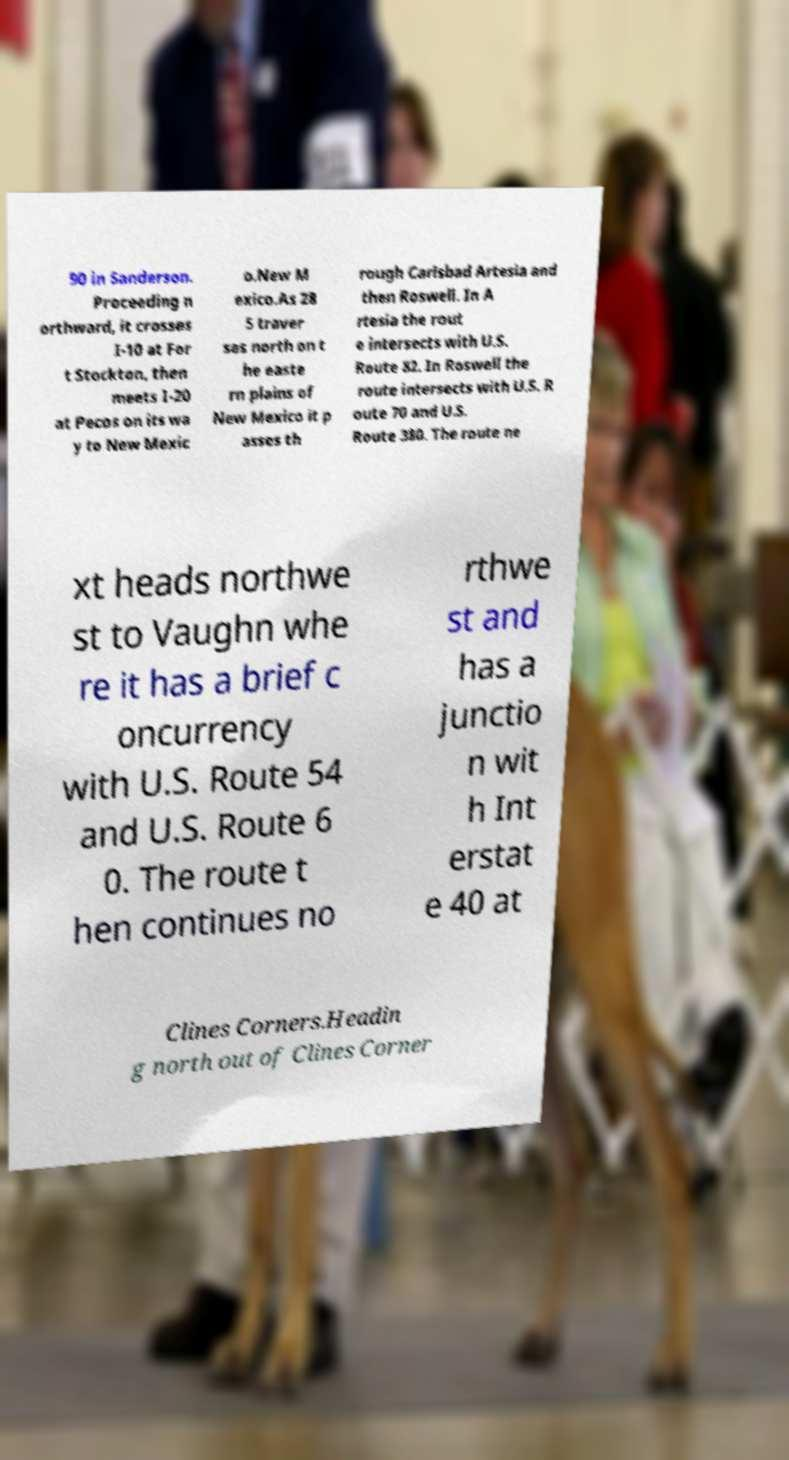Could you assist in decoding the text presented in this image and type it out clearly? 90 in Sanderson. Proceeding n orthward, it crosses I-10 at For t Stockton, then meets I-20 at Pecos on its wa y to New Mexic o.New M exico.As 28 5 traver ses north on t he easte rn plains of New Mexico it p asses th rough Carlsbad Artesia and then Roswell. In A rtesia the rout e intersects with U.S. Route 82. In Roswell the route intersects with U.S. R oute 70 and U.S. Route 380. The route ne xt heads northwe st to Vaughn whe re it has a brief c oncurrency with U.S. Route 54 and U.S. Route 6 0. The route t hen continues no rthwe st and has a junctio n wit h Int erstat e 40 at Clines Corners.Headin g north out of Clines Corner 